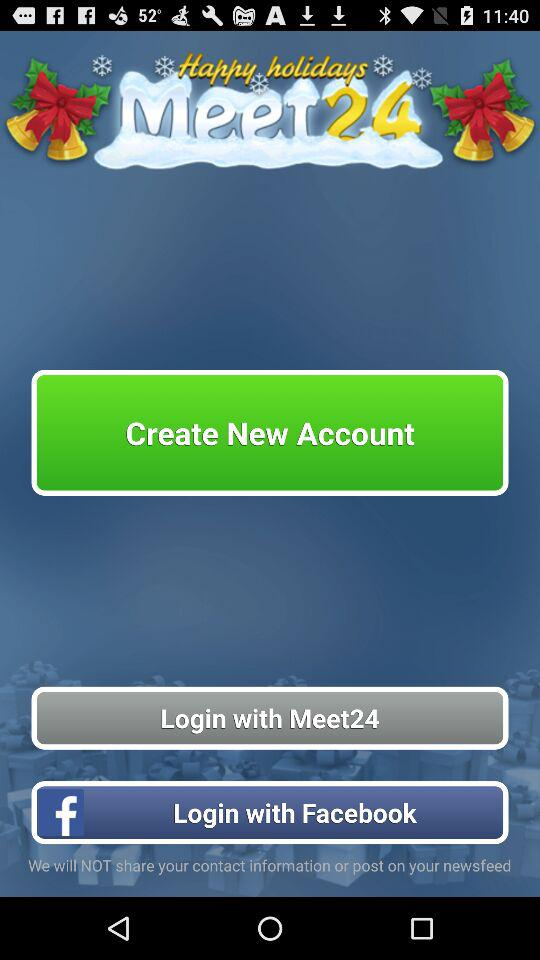What is the name of the application? The name of the application is "Meet24". 